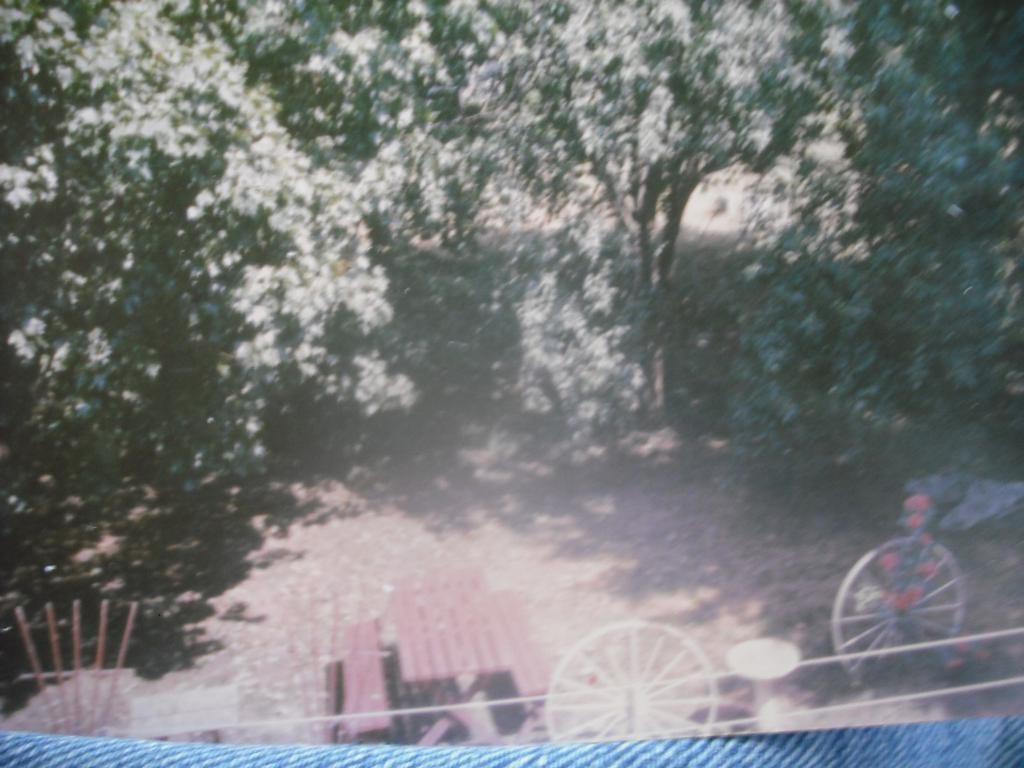What type of vegetation can be seen in the image? There are trees in the image. What type of seating is available in the image? There are wooden benches in the image. What type of furniture is present in the image? There is a table in the image. What type of object has two wheels in the image? There are two wheels in the image, but the object they belong to is not specified. How many cats are sitting on the wooden benches in the image? There are no cats present in the image. What type of work is being done at the table in the image? The image does not show any work being done at the table; it only shows the presence of a table. 